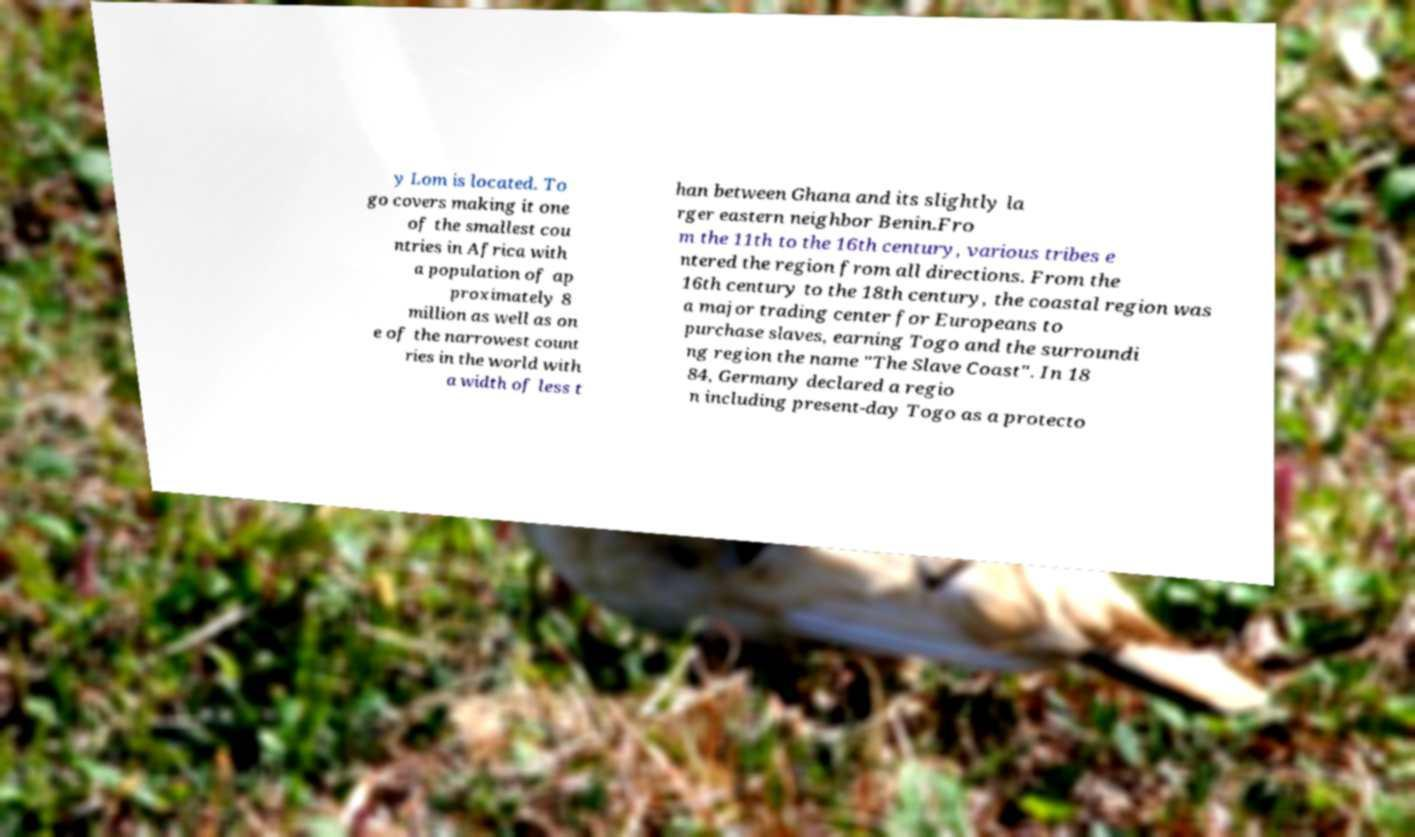Can you read and provide the text displayed in the image?This photo seems to have some interesting text. Can you extract and type it out for me? y Lom is located. To go covers making it one of the smallest cou ntries in Africa with a population of ap proximately 8 million as well as on e of the narrowest count ries in the world with a width of less t han between Ghana and its slightly la rger eastern neighbor Benin.Fro m the 11th to the 16th century, various tribes e ntered the region from all directions. From the 16th century to the 18th century, the coastal region was a major trading center for Europeans to purchase slaves, earning Togo and the surroundi ng region the name "The Slave Coast". In 18 84, Germany declared a regio n including present-day Togo as a protecto 